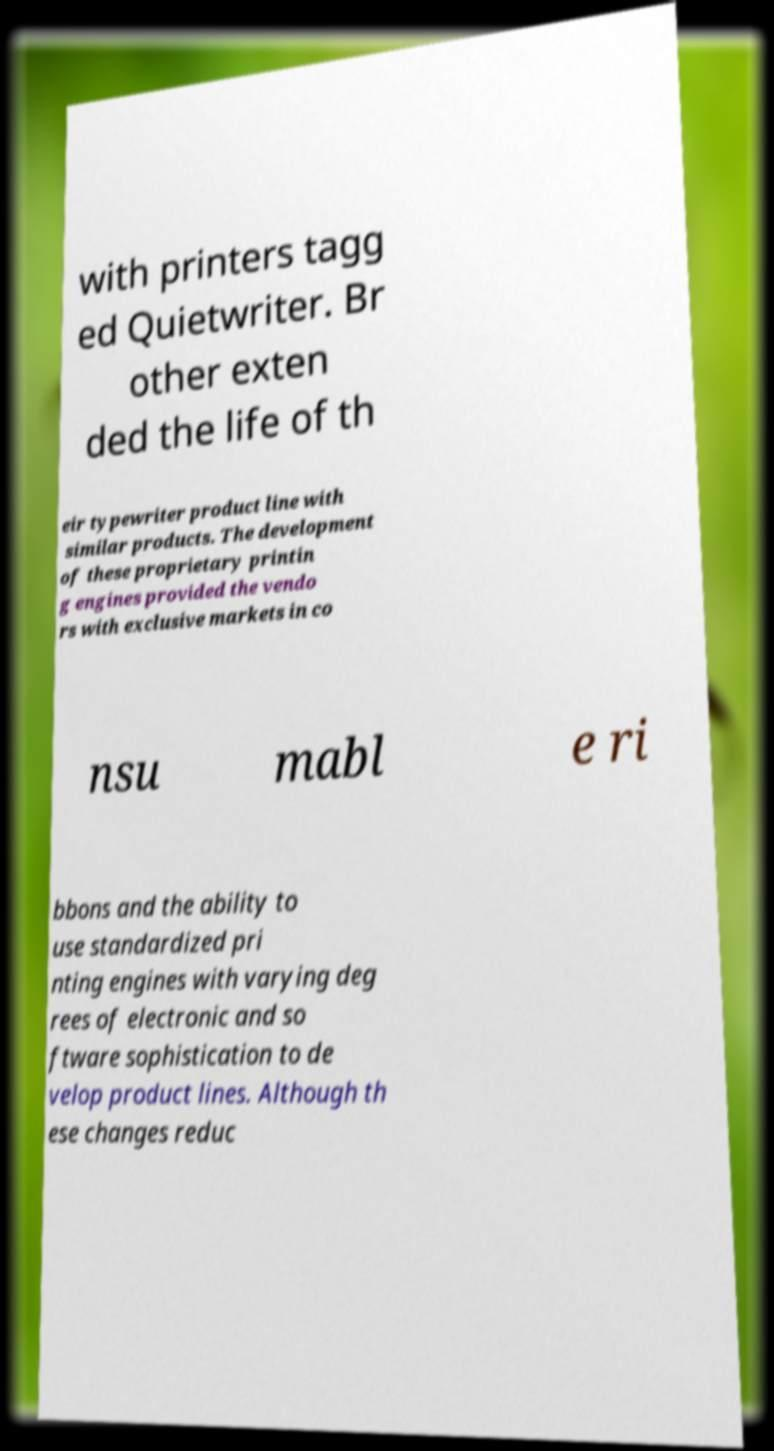What messages or text are displayed in this image? I need them in a readable, typed format. with printers tagg ed Quietwriter. Br other exten ded the life of th eir typewriter product line with similar products. The development of these proprietary printin g engines provided the vendo rs with exclusive markets in co nsu mabl e ri bbons and the ability to use standardized pri nting engines with varying deg rees of electronic and so ftware sophistication to de velop product lines. Although th ese changes reduc 